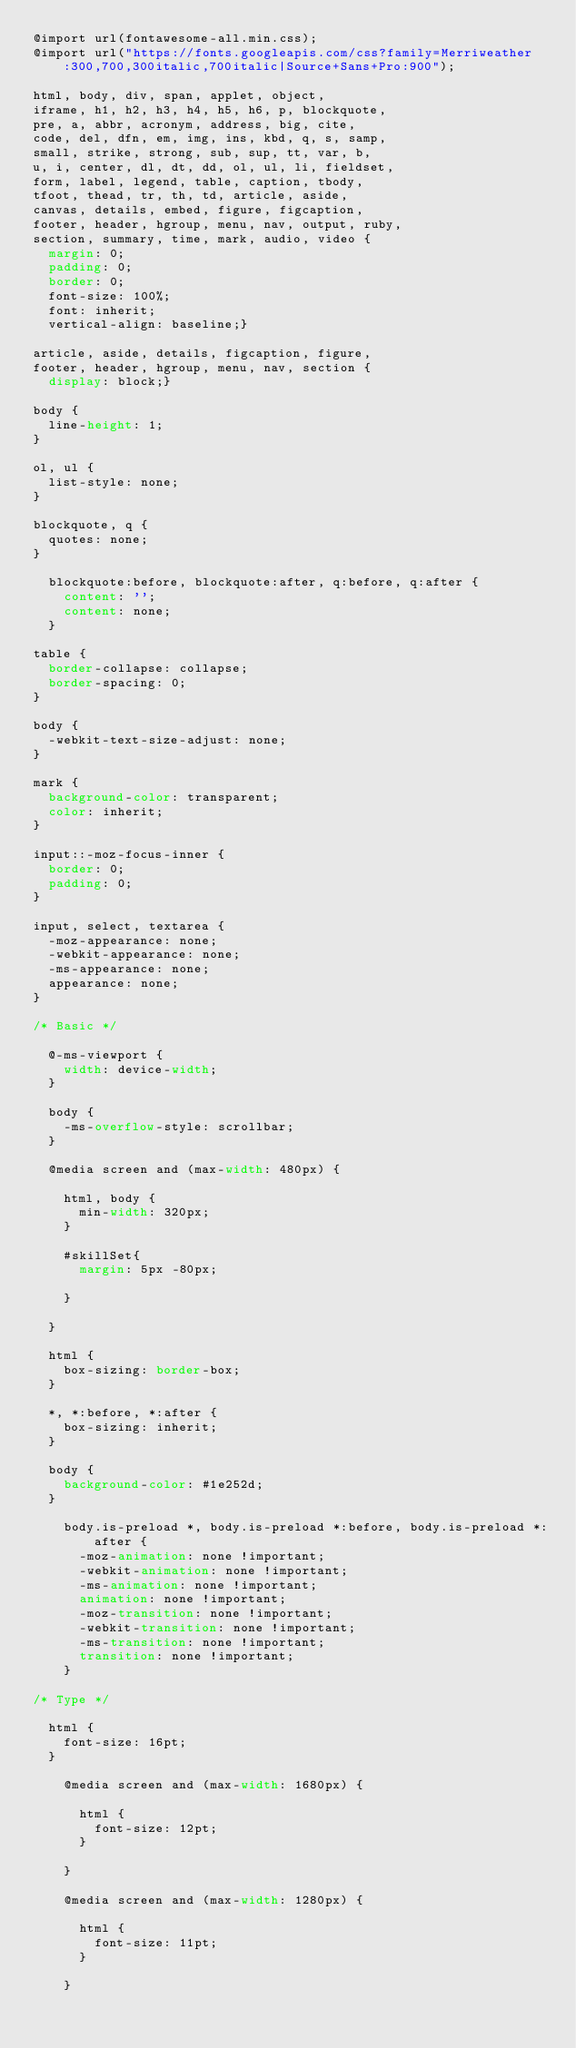<code> <loc_0><loc_0><loc_500><loc_500><_CSS_>@import url(fontawesome-all.min.css);
@import url("https://fonts.googleapis.com/css?family=Merriweather:300,700,300italic,700italic|Source+Sans+Pro:900");

html, body, div, span, applet, object,
iframe, h1, h2, h3, h4, h5, h6, p, blockquote,
pre, a, abbr, acronym, address, big, cite,
code, del, dfn, em, img, ins, kbd, q, s, samp,
small, strike, strong, sub, sup, tt, var, b,
u, i, center, dl, dt, dd, ol, ul, li, fieldset,
form, label, legend, table, caption, tbody,
tfoot, thead, tr, th, td, article, aside,
canvas, details, embed, figure, figcaption,
footer, header, hgroup, menu, nav, output, ruby,
section, summary, time, mark, audio, video {
	margin: 0;
	padding: 0;
	border: 0;
	font-size: 100%;
	font: inherit;
	vertical-align: baseline;}

article, aside, details, figcaption, figure,
footer, header, hgroup, menu, nav, section {
	display: block;}

body {
	line-height: 1;
}

ol, ul {
	list-style: none;
}

blockquote, q {
	quotes: none;
}

	blockquote:before, blockquote:after, q:before, q:after {
		content: '';
		content: none;
	}

table {
	border-collapse: collapse;
	border-spacing: 0;
}

body {
	-webkit-text-size-adjust: none;
}

mark {
	background-color: transparent;
	color: inherit;
}

input::-moz-focus-inner {
	border: 0;
	padding: 0;
}

input, select, textarea {
	-moz-appearance: none;
	-webkit-appearance: none;
	-ms-appearance: none;
	appearance: none;
}

/* Basic */

	@-ms-viewport {
		width: device-width;
	}

	body {
		-ms-overflow-style: scrollbar;
	}

	@media screen and (max-width: 480px) {

		html, body {
			min-width: 320px;
		}

		#skillSet{
			margin: 5px -80px;

		}

	}

	html {
		box-sizing: border-box;
	}

	*, *:before, *:after {
		box-sizing: inherit;
	}

	body {
		background-color: #1e252d;
	}

		body.is-preload *, body.is-preload *:before, body.is-preload *:after {
			-moz-animation: none !important;
			-webkit-animation: none !important;
			-ms-animation: none !important;
			animation: none !important;
			-moz-transition: none !important;
			-webkit-transition: none !important;
			-ms-transition: none !important;
			transition: none !important;
		}

/* Type */

	html {
		font-size: 16pt;
	}

		@media screen and (max-width: 1680px) {

			html {
				font-size: 12pt;
			}

		}

		@media screen and (max-width: 1280px) {

			html {
				font-size: 11pt;
			}

		}
</code> 